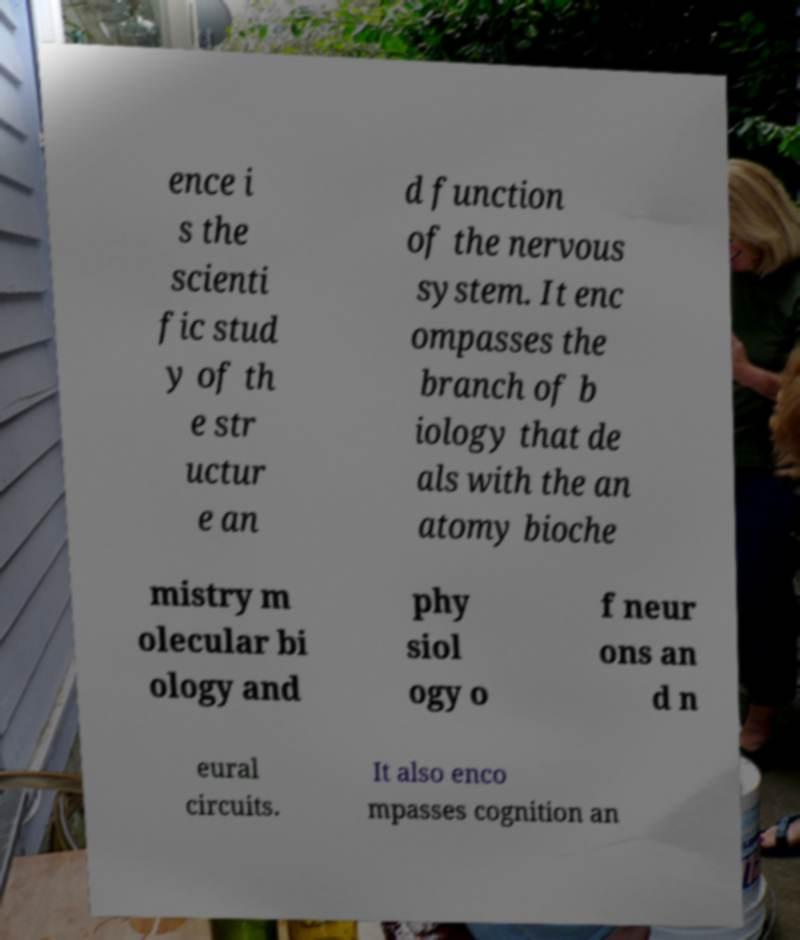Please identify and transcribe the text found in this image. ence i s the scienti fic stud y of th e str uctur e an d function of the nervous system. It enc ompasses the branch of b iology that de als with the an atomy bioche mistry m olecular bi ology and phy siol ogy o f neur ons an d n eural circuits. It also enco mpasses cognition an 